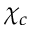<formula> <loc_0><loc_0><loc_500><loc_500>\chi _ { c }</formula> 